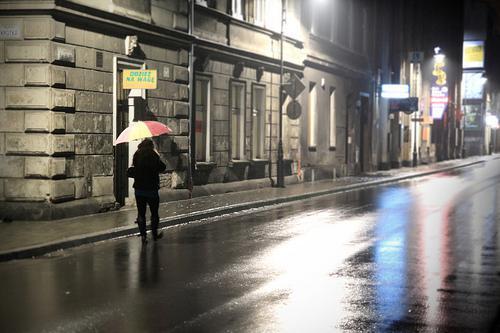How many umbrellas are shown?
Give a very brief answer. 1. 